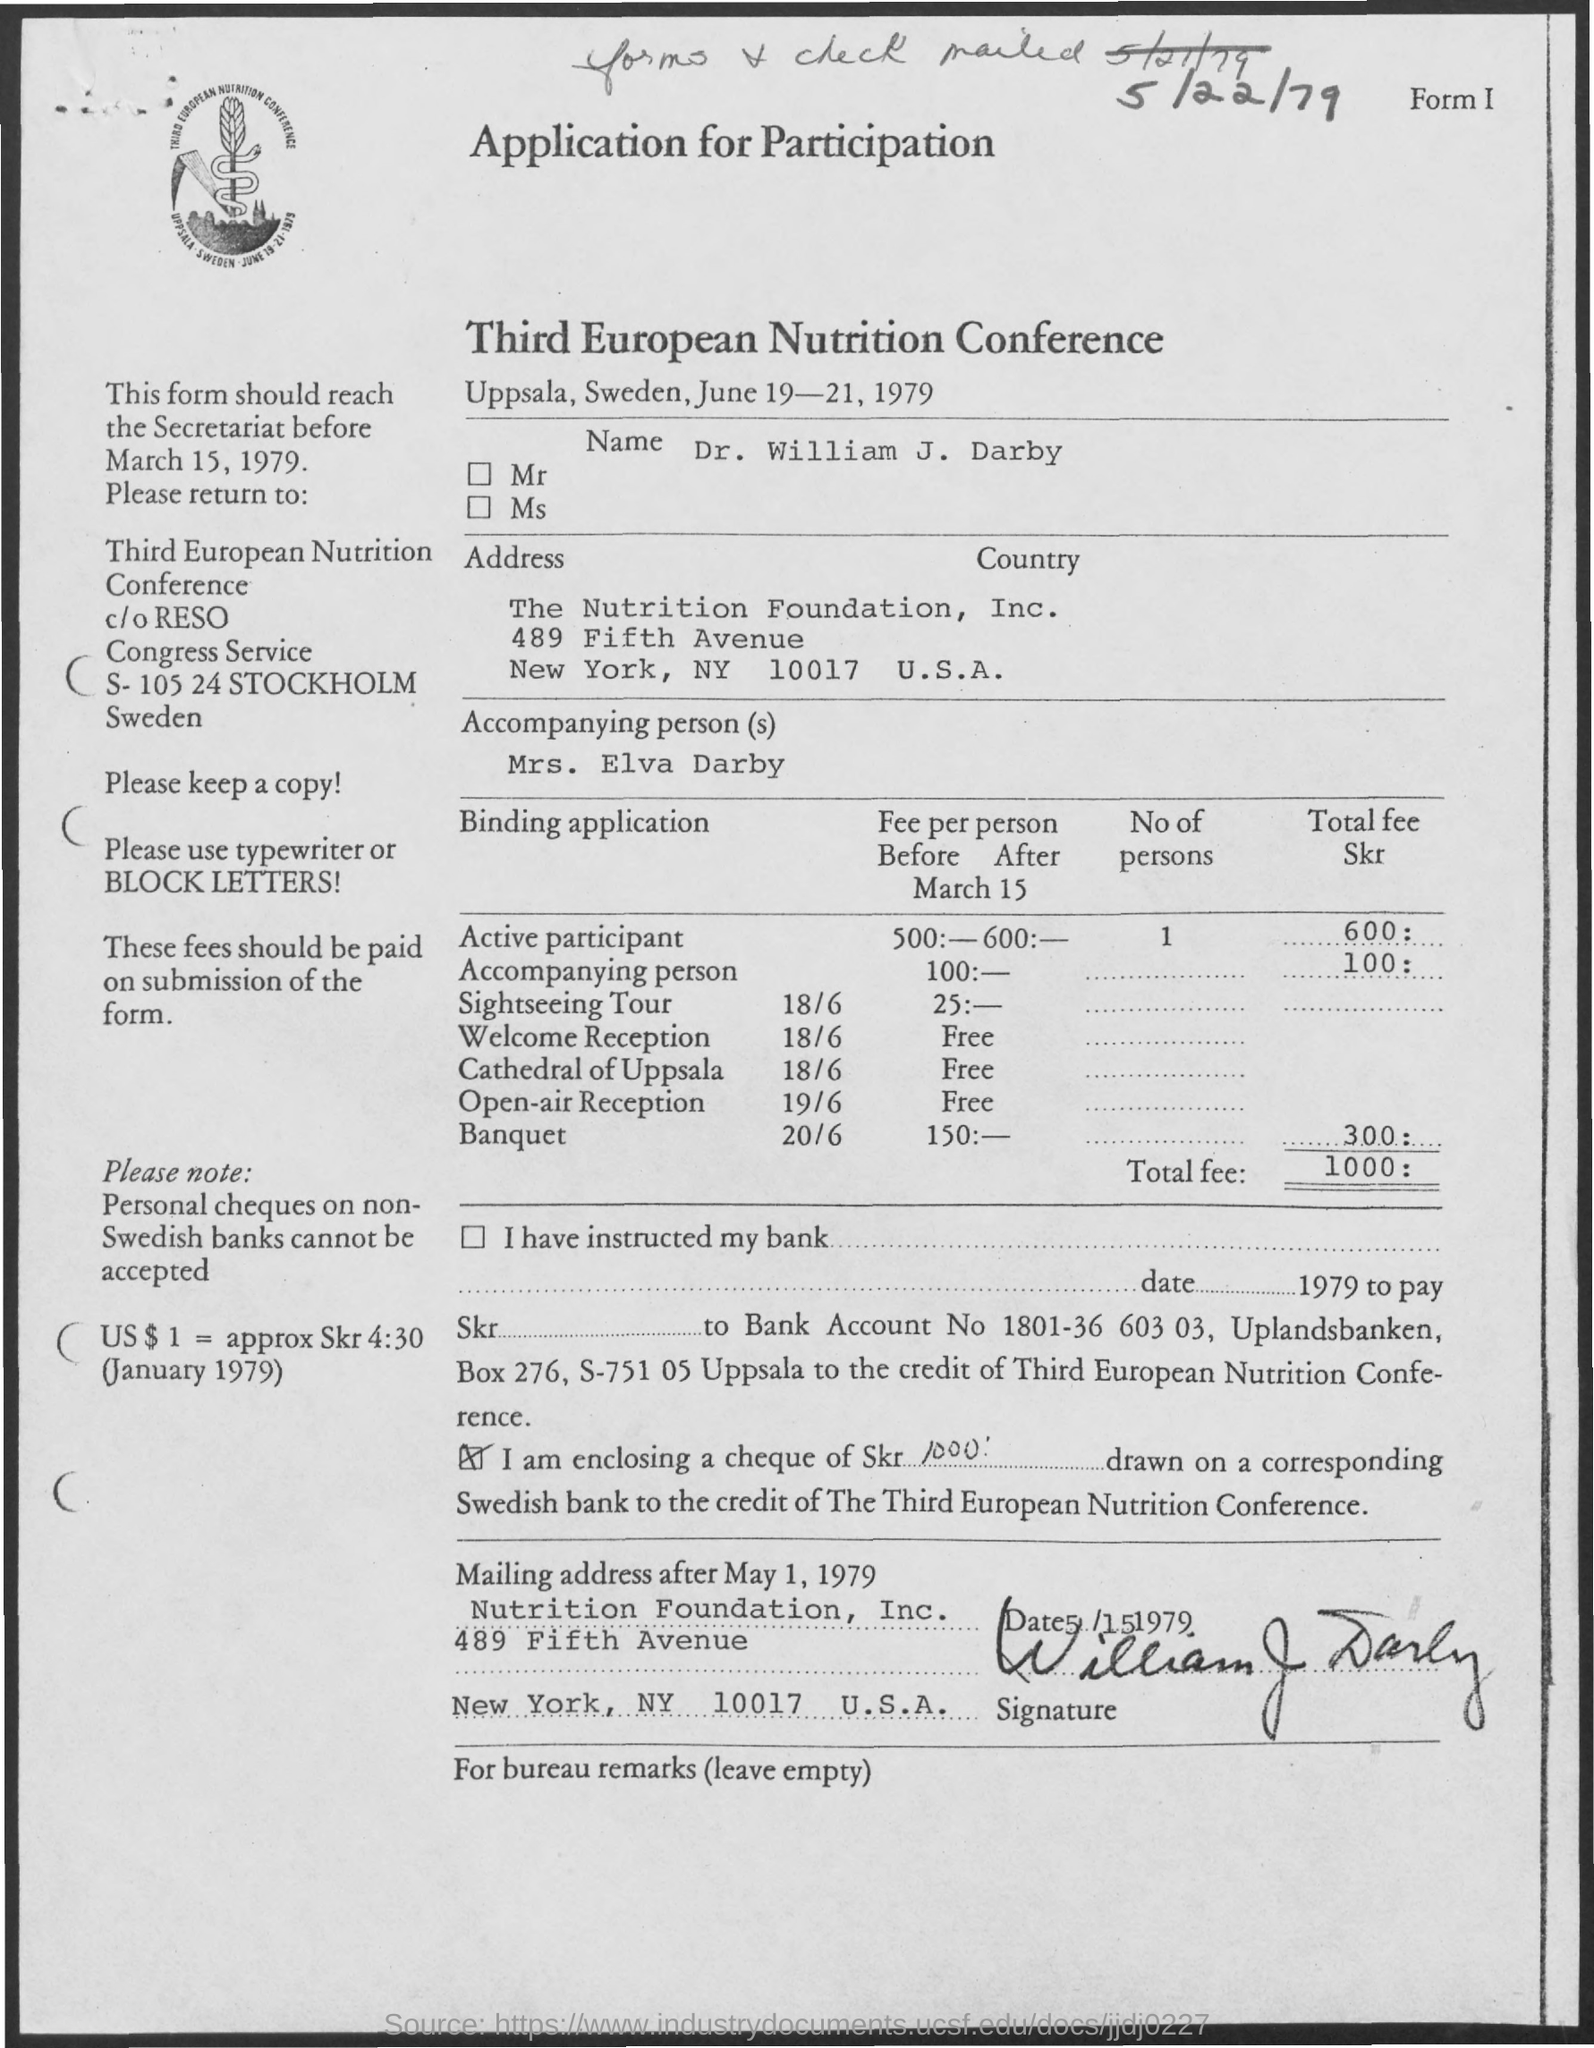What is the name of the conference ?
Provide a succinct answer. Third European Nutrition Conference. What is the name mentioned in the given application ?
Your answer should be compact. Dr. William J. Darby. When was the third european nutrition conference was scheduled ?
Make the answer very short. June 19-21, 1979. What is the amount of total fee mentioned in the given application ?
Your answer should be very brief. 1000:. 